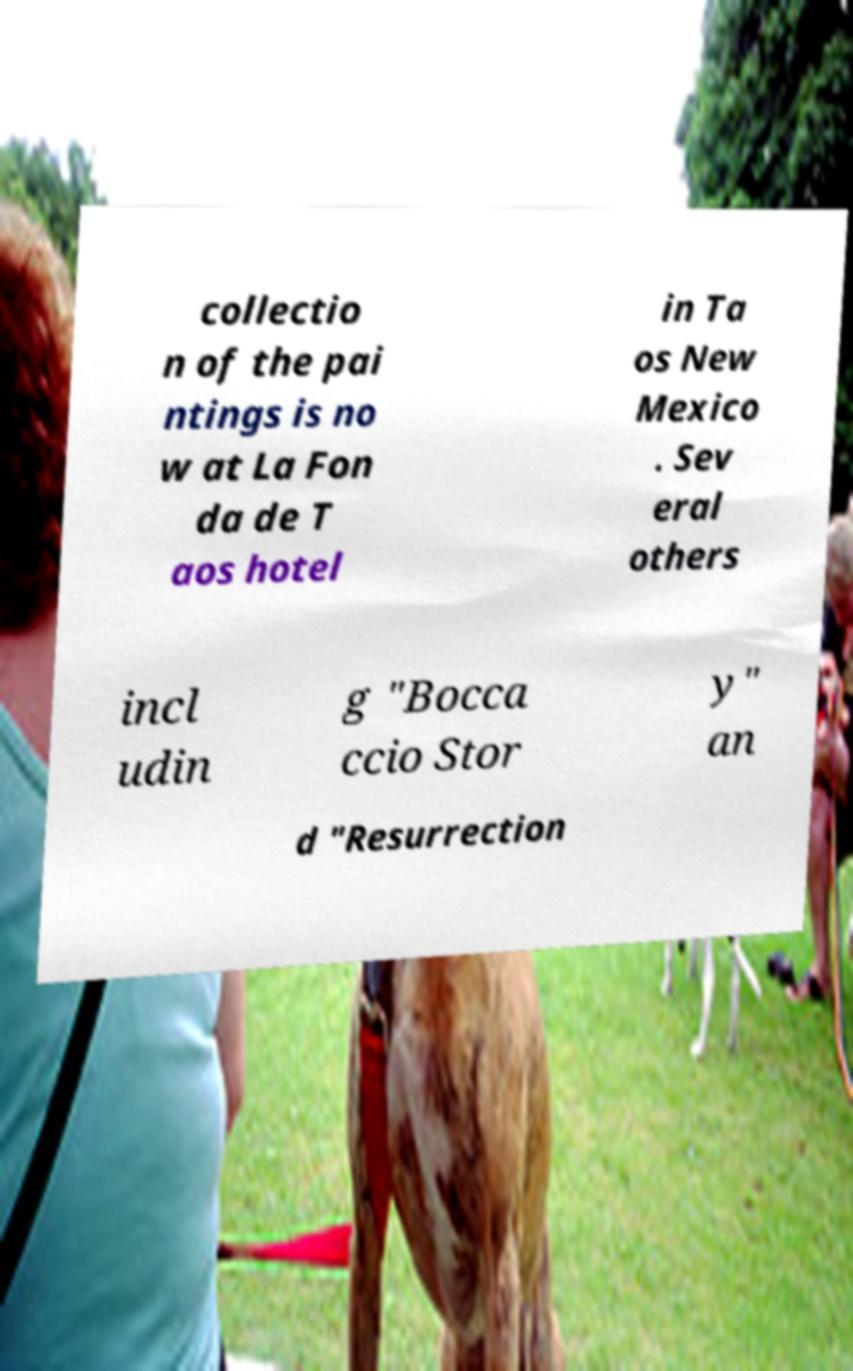I need the written content from this picture converted into text. Can you do that? collectio n of the pai ntings is no w at La Fon da de T aos hotel in Ta os New Mexico . Sev eral others incl udin g "Bocca ccio Stor y" an d "Resurrection 